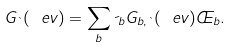Convert formula to latex. <formula><loc_0><loc_0><loc_500><loc_500>G _ { \theta } ( \ e v ) = \sum _ { b } \psi _ { b } G _ { b , \theta } ( \ e v ) \phi _ { b } .</formula> 